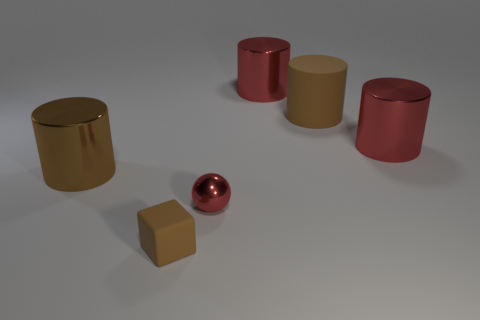Add 2 big brown cylinders. How many objects exist? 8 Subtract all blocks. How many objects are left? 5 Subtract all large brown matte things. Subtract all brown metallic cylinders. How many objects are left? 4 Add 1 tiny red shiny objects. How many tiny red shiny objects are left? 2 Add 3 brown cubes. How many brown cubes exist? 4 Subtract 0 green cubes. How many objects are left? 6 